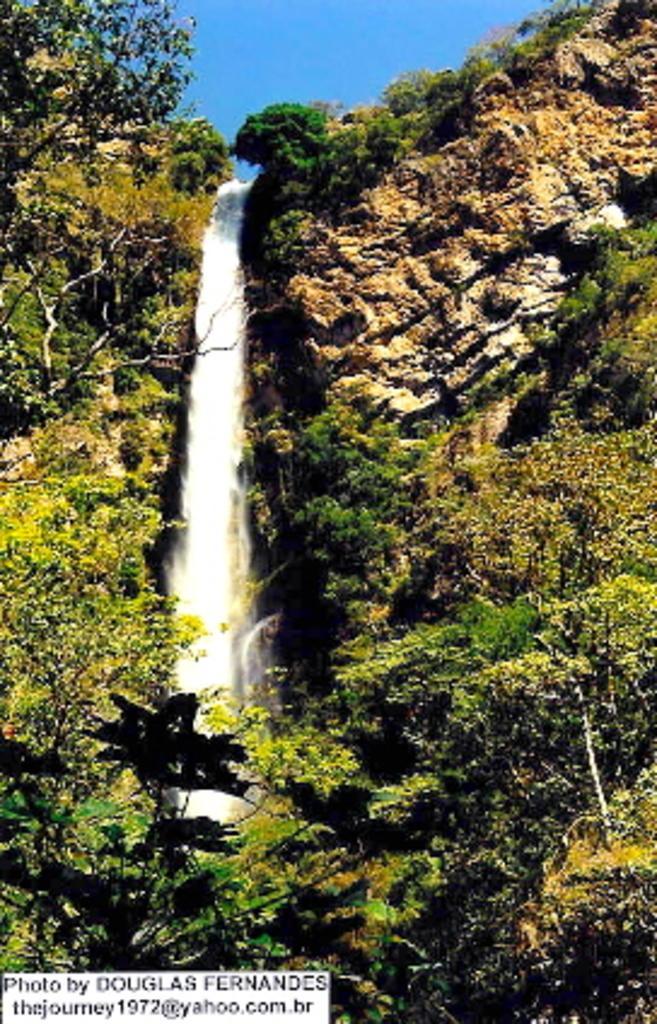Describe this image in one or two sentences. In this image I can see a huge rocky mountain and few trees on the mountain which are green, orange and yellow in color. I can see the waterfall from the top of the mountain. I can see the sky in the background. 